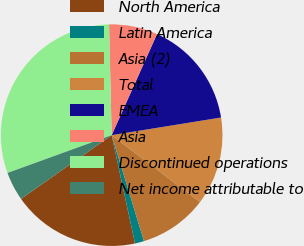<chart> <loc_0><loc_0><loc_500><loc_500><pie_chart><fcel>North America<fcel>Latin America<fcel>Asia (2)<fcel>Total<fcel>EMEA<fcel>Asia<fcel>Discontinued operations<fcel>Net income attributable to<nl><fcel>18.63%<fcel>1.33%<fcel>9.98%<fcel>12.86%<fcel>15.74%<fcel>7.09%<fcel>30.16%<fcel>4.21%<nl></chart> 